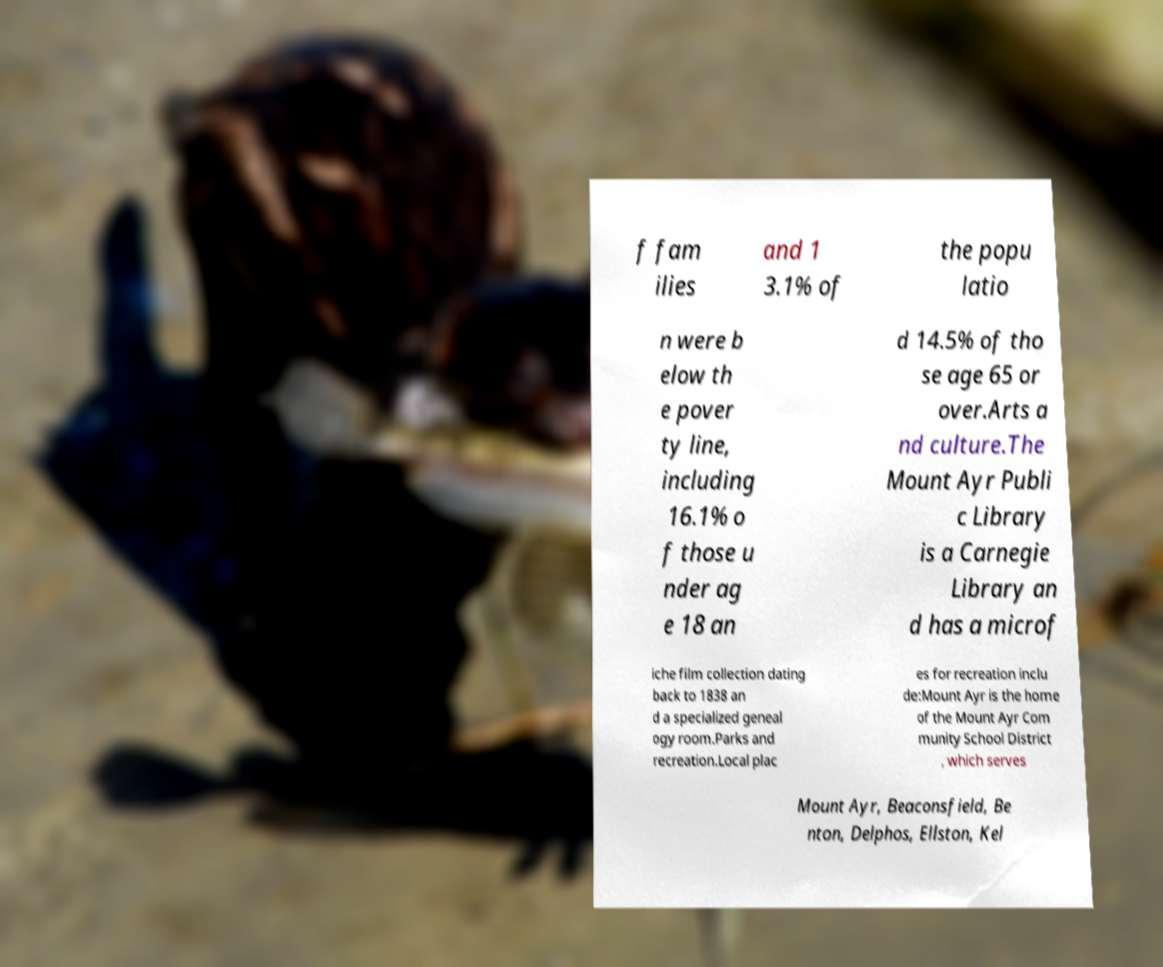I need the written content from this picture converted into text. Can you do that? f fam ilies and 1 3.1% of the popu latio n were b elow th e pover ty line, including 16.1% o f those u nder ag e 18 an d 14.5% of tho se age 65 or over.Arts a nd culture.The Mount Ayr Publi c Library is a Carnegie Library an d has a microf iche film collection dating back to 1838 an d a specialized geneal ogy room.Parks and recreation.Local plac es for recreation inclu de:Mount Ayr is the home of the Mount Ayr Com munity School District , which serves Mount Ayr, Beaconsfield, Be nton, Delphos, Ellston, Kel 